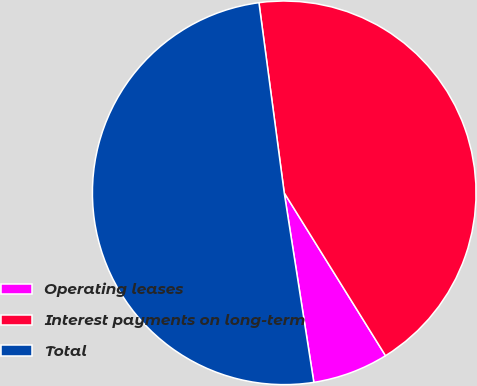<chart> <loc_0><loc_0><loc_500><loc_500><pie_chart><fcel>Operating leases<fcel>Interest payments on long-term<fcel>Total<nl><fcel>6.39%<fcel>43.25%<fcel>50.37%<nl></chart> 